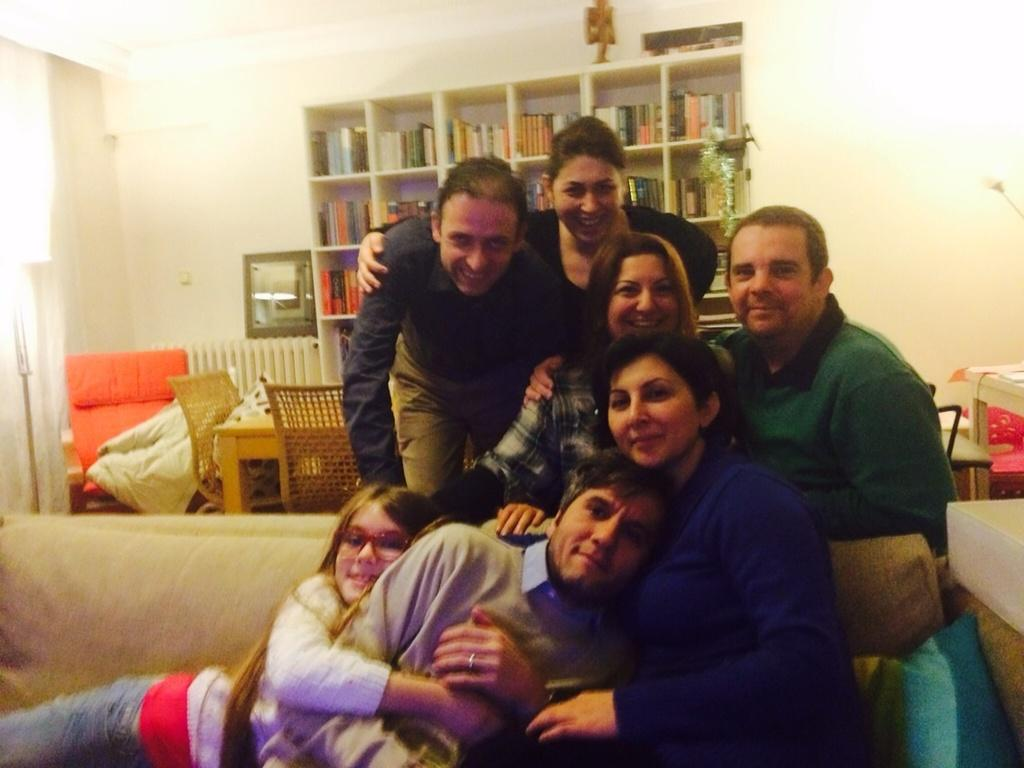Who or what is present in the image? There are people in the image. What can be seen in the background or surrounding the people? There are bookshelves visible in the image. How many cups can be seen in the image? There is no cup present in the image. Are there any brothers among the people in the image? The image does not provide information about the relationships between the people, so it cannot be determined if there are any brothers among them. 